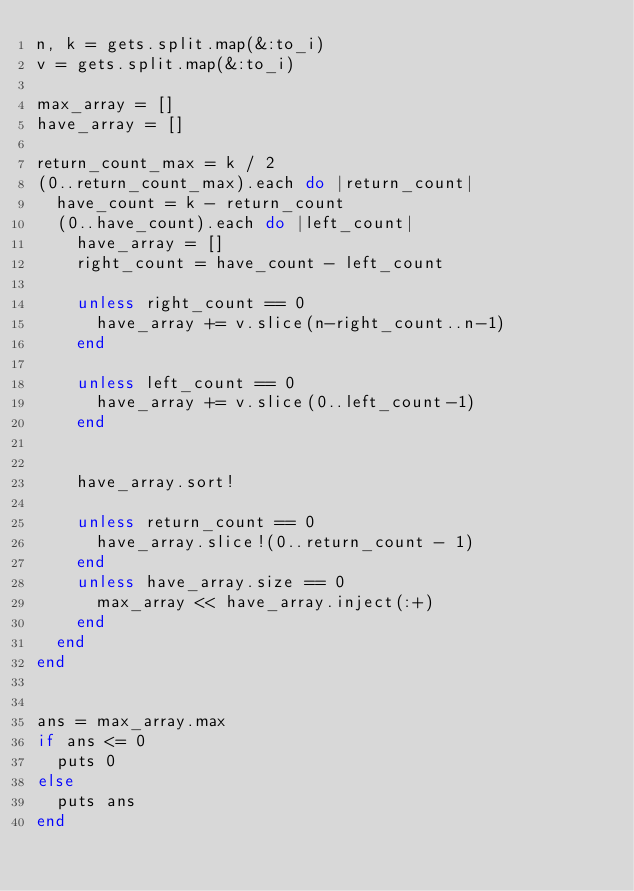Convert code to text. <code><loc_0><loc_0><loc_500><loc_500><_Ruby_>n, k = gets.split.map(&:to_i)
v = gets.split.map(&:to_i)

max_array = []
have_array = []

return_count_max = k / 2
(0..return_count_max).each do |return_count|
  have_count = k - return_count
  (0..have_count).each do |left_count|
    have_array = []
    right_count = have_count - left_count

    unless right_count == 0
      have_array += v.slice(n-right_count..n-1)
    end

    unless left_count == 0
      have_array += v.slice(0..left_count-1)
    end


    have_array.sort!

    unless return_count == 0
      have_array.slice!(0..return_count - 1)
    end
    unless have_array.size == 0
      max_array << have_array.inject(:+)
    end
  end
end


ans = max_array.max
if ans <= 0
  puts 0
else
  puts ans
end</code> 